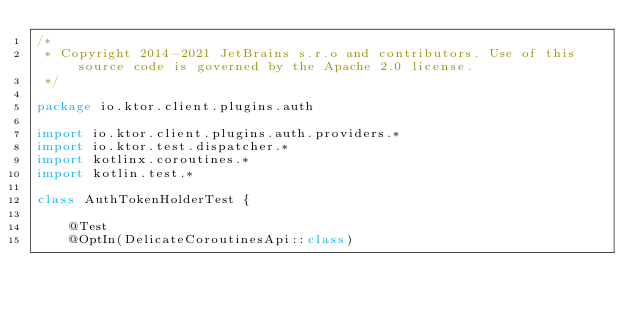<code> <loc_0><loc_0><loc_500><loc_500><_Kotlin_>/*
 * Copyright 2014-2021 JetBrains s.r.o and contributors. Use of this source code is governed by the Apache 2.0 license.
 */

package io.ktor.client.plugins.auth

import io.ktor.client.plugins.auth.providers.*
import io.ktor.test.dispatcher.*
import kotlinx.coroutines.*
import kotlin.test.*

class AuthTokenHolderTest {

    @Test
    @OptIn(DelicateCoroutinesApi::class)</code> 